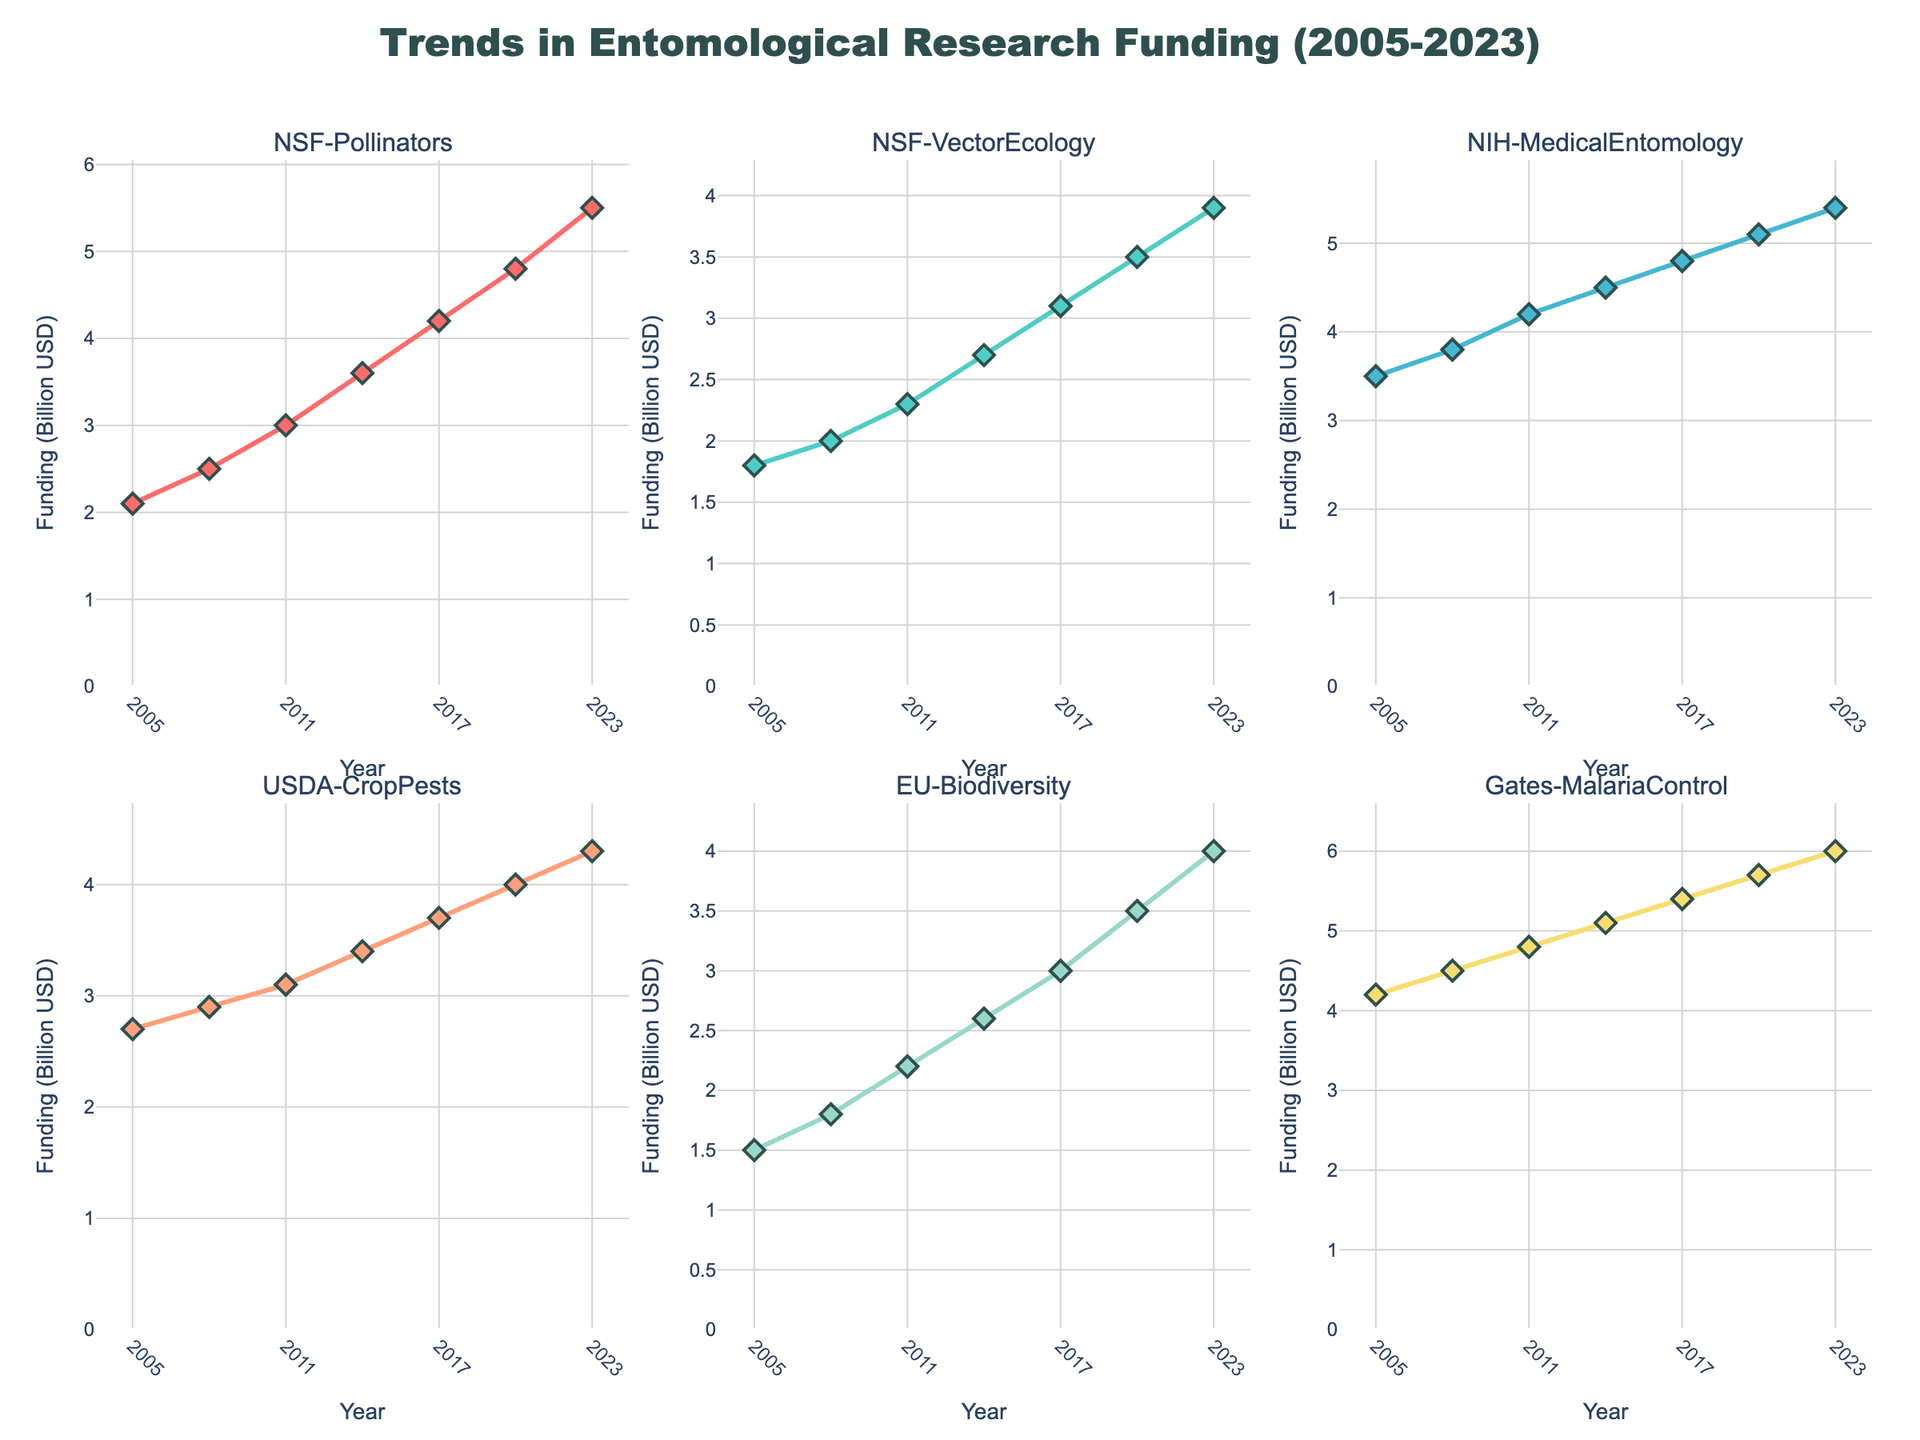Which research area received the highest funding from Gates Foundation in 2023? From the subplot titled "Gates-MalariaControl", the line reaches its highest value in 2023, which is 6.0 billion USD.
Answer: Malaria control What is the general trend of funding for NSF-Pollinators from 2005 to 2023? The subplot titled "NSF-Pollinators" shows a steadily increasing line from 2.1 billion USD in 2005 to 5.5 billion USD in 2023.
Answer: Increasing How much did NIH-MedicalEntomology funding increase from 2005 to 2023? The subplot titled "NIH-MedicalEntomology" starts at 3.5 billion USD in 2005 and increases to 5.4 billion USD in 2023. The difference is 5.4 - 3.5.
Answer: 1.9 billion USD Which agency's funding shows the least variation over the years? By examining the visual slopes of all subplots, the USDA-CropPests line appears relatively more stable without steep slopes.
Answer: USDA-CropPests Compare the funding trends for NSF-VectorEcology and EU-Biodiversity. Which one shows a steeper increase? NSF-VectorEcology starts at 1.8 billion USD in 2005 and goes to 3.9 billion USD in 2023. EU-Biodiversity starts at 1.5 billion USD in 2005 and ends at 4.0 billion USD in 2023. The increase for EU-Biodiversity (2.5 billion USD) is slightly more than NSF-VectorEcology (2.1 billion USD).
Answer: EU-Biodiversity Identify the time period with the largest funding increase for NSF-Pollinators. The NSF-Pollinators subplot shows the largest increase between 2011 (3.0 billion USD) and 2014 (3.6 billion USD) with an increase of 0.6 billion USD.
Answer: 2011 to 2014 What is the trend of funding for USDA-CropPests from 2005 to 2023 and how does it compare with that of Gates-MalariaControl? USDA-CropPests shows a steady increase from 2.7 billion USD in 2005 to 4.3 billion USD in 2023, while Gates-MalariaControl starts at a higher base of 4.2 billion USD in 2005 and rises to 6.0 billion USD in 2023, with steeper slopes indicating more significant increases.
Answer: Steady increase for USDA-CropPests; steeper increase for Gates-MalariaControl Is the funding for NIH-MedicalEntomology in 2020 closer to the funding for NSF-Pollinators in 2014 or 2023? NIH-MedicalEntomology in 2020 is 5.1 billion USD. NSF-Pollinators in 2014 is 3.6 billion USD and in 2023 is 5.5 billion USD. 5.1 billion USD is closer to 5.5 billion USD.
Answer: NSF-Pollinators in 2023 Which years show the same funding level for NSF-VectorEcology and Gates-MalariaControl? There are no years where NSF-VectorEcology and Gates-MalariaControl show the same funding level.
Answer: None 